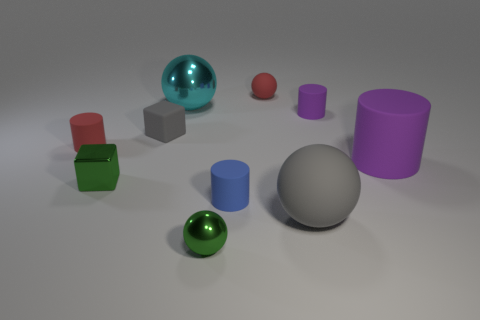Subtract all cylinders. How many objects are left? 6 Add 6 tiny gray blocks. How many tiny gray blocks exist? 7 Subtract 0 brown spheres. How many objects are left? 10 Subtract all big cylinders. Subtract all big purple matte cylinders. How many objects are left? 8 Add 5 tiny red rubber spheres. How many tiny red rubber spheres are left? 6 